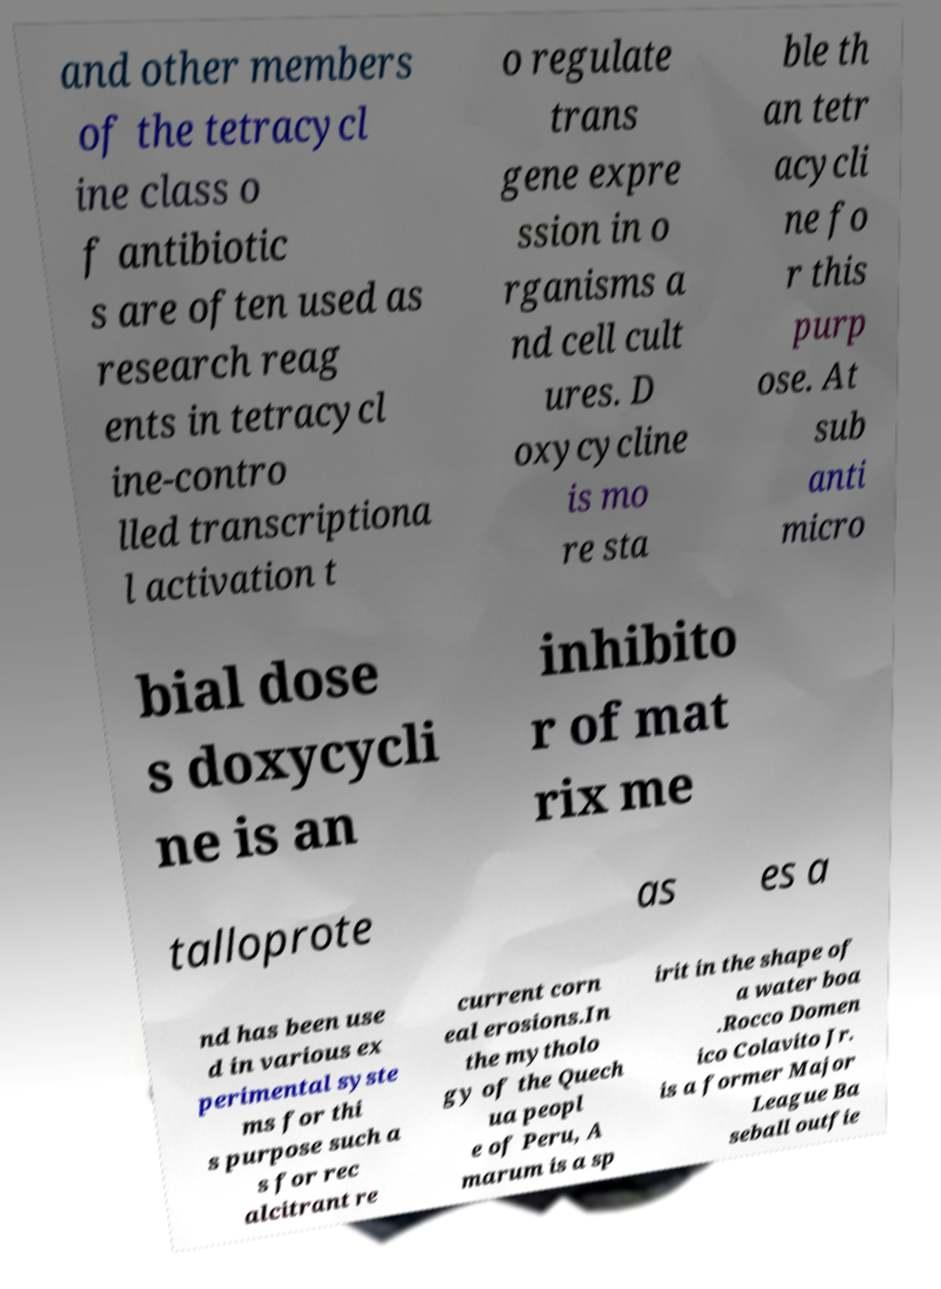What messages or text are displayed in this image? I need them in a readable, typed format. and other members of the tetracycl ine class o f antibiotic s are often used as research reag ents in tetracycl ine-contro lled transcriptiona l activation t o regulate trans gene expre ssion in o rganisms a nd cell cult ures. D oxycycline is mo re sta ble th an tetr acycli ne fo r this purp ose. At sub anti micro bial dose s doxycycli ne is an inhibito r of mat rix me talloprote as es a nd has been use d in various ex perimental syste ms for thi s purpose such a s for rec alcitrant re current corn eal erosions.In the mytholo gy of the Quech ua peopl e of Peru, A marum is a sp irit in the shape of a water boa .Rocco Domen ico Colavito Jr. is a former Major League Ba seball outfie 